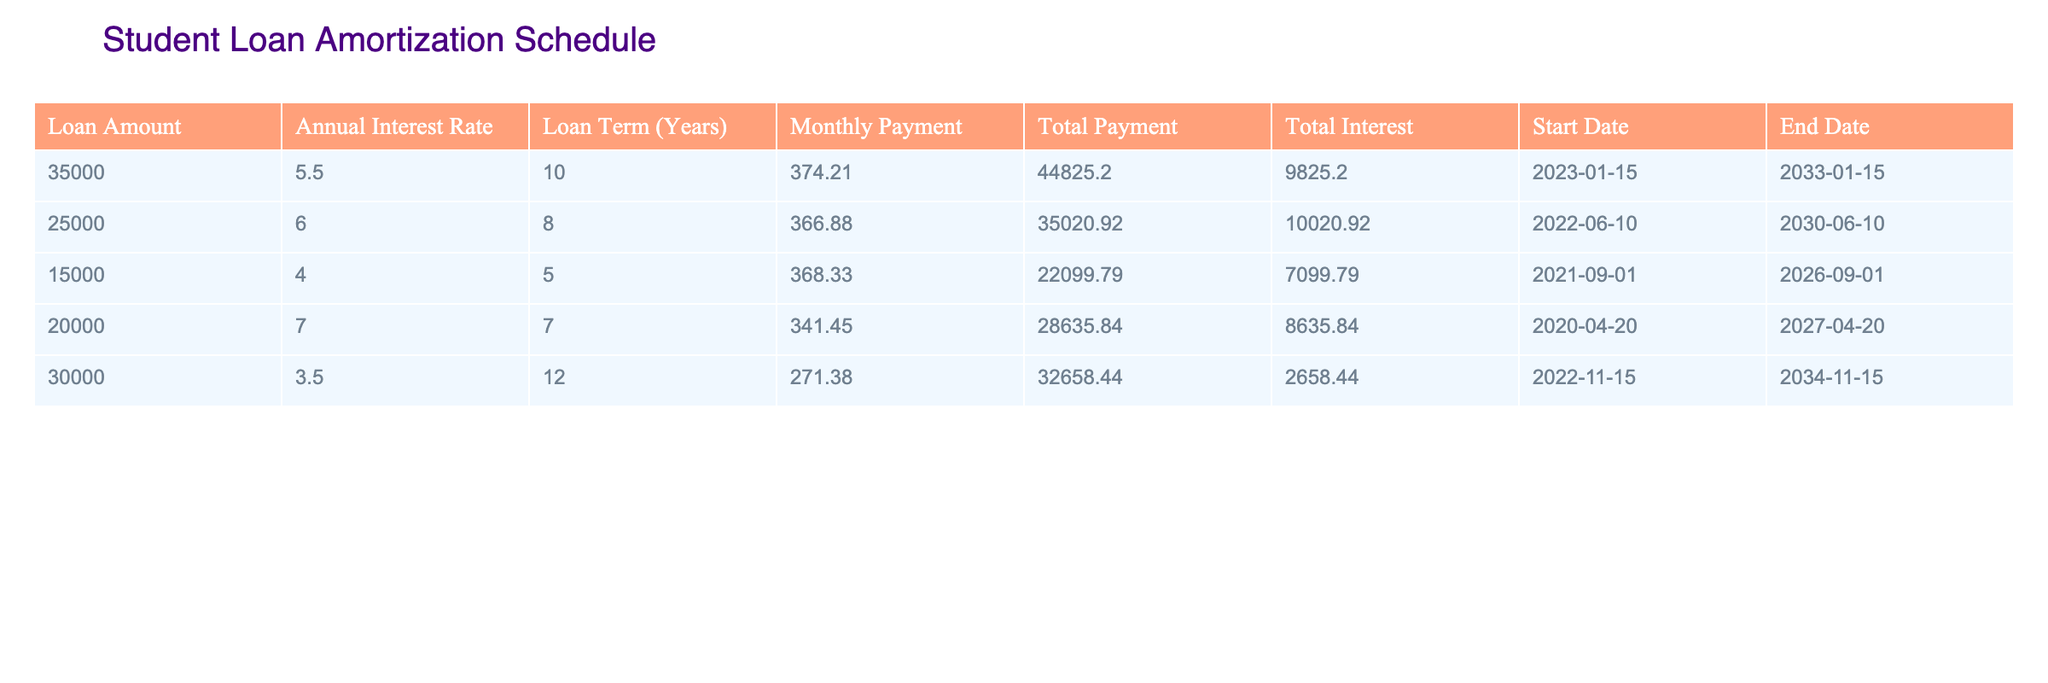What is the total payment for the loan of 35,000? From the table, the total payment for the loan amount of 35,000 is listed directly under the Total Payment column. It shows that the total payment is 44825.20.
Answer: 44825.20 How long is the repayment term for the loan with the highest interest rate? Looking at the Interest Rate column, the highest rate is 7.0. The corresponding repaid term from the Loan Term column is 7 years.
Answer: 7 years What is the monthly payment for the 25,000 loan? In the table, the monthly payment for the loan amount of 25,000 is found in the Monthly Payment column. It is listed as 366.88.
Answer: 366.88 Is the total interest paid for the 20,000 loan greater than for the 15,000 loan? The total interest for the 20,000 loan is 8635.84 and for the 15,000 loan, it is 7099.79. Since 8635.84 is greater than 7099.79, the statement is true.
Answer: Yes What is the average total interest paid across all loans? To find the average total interest, sum the total interest values: 9825.20 + 10020.92 + 7099.79 + 8635.84 + 2658.44 = 42030.19. Then divide by the number of loans (5), giving 42030.19 / 5 = 8406.038, which rounds to 8406.04.
Answer: 8406.04 Which loan has the lowest monthly payment, and what is that payment? Referring to the Monthly Payment column, the lowest value is found for the loan of 30,000, which has a monthly payment of 271.38.
Answer: 271.38 What is the total principal amount for loans starting in 2022? The loans starting in 2022 are 25,000 and 30,000. Adding these together gives a total principal of 25,000 + 30,000 = 55,000.
Answer: 55000 Are all the loans scheduled to end in a month of January? The loans end in January (35,000), June (25,000), September (15,000), April (20,000), and November (30,000). Since there are loans ending in months other than January, the answer is false.
Answer: No 